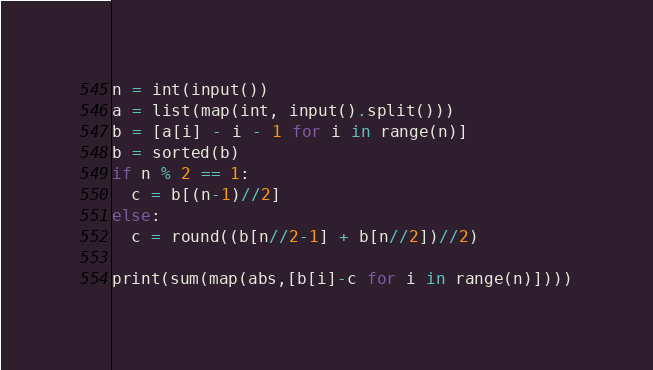<code> <loc_0><loc_0><loc_500><loc_500><_Python_>n = int(input())
a = list(map(int, input().split()))
b = [a[i] - i - 1 for i in range(n)]
b = sorted(b)
if n % 2 == 1:
  c = b[(n-1)//2]
else:
  c = round((b[n//2-1] + b[n//2])//2)

print(sum(map(abs,[b[i]-c for i in range(n)])))</code> 